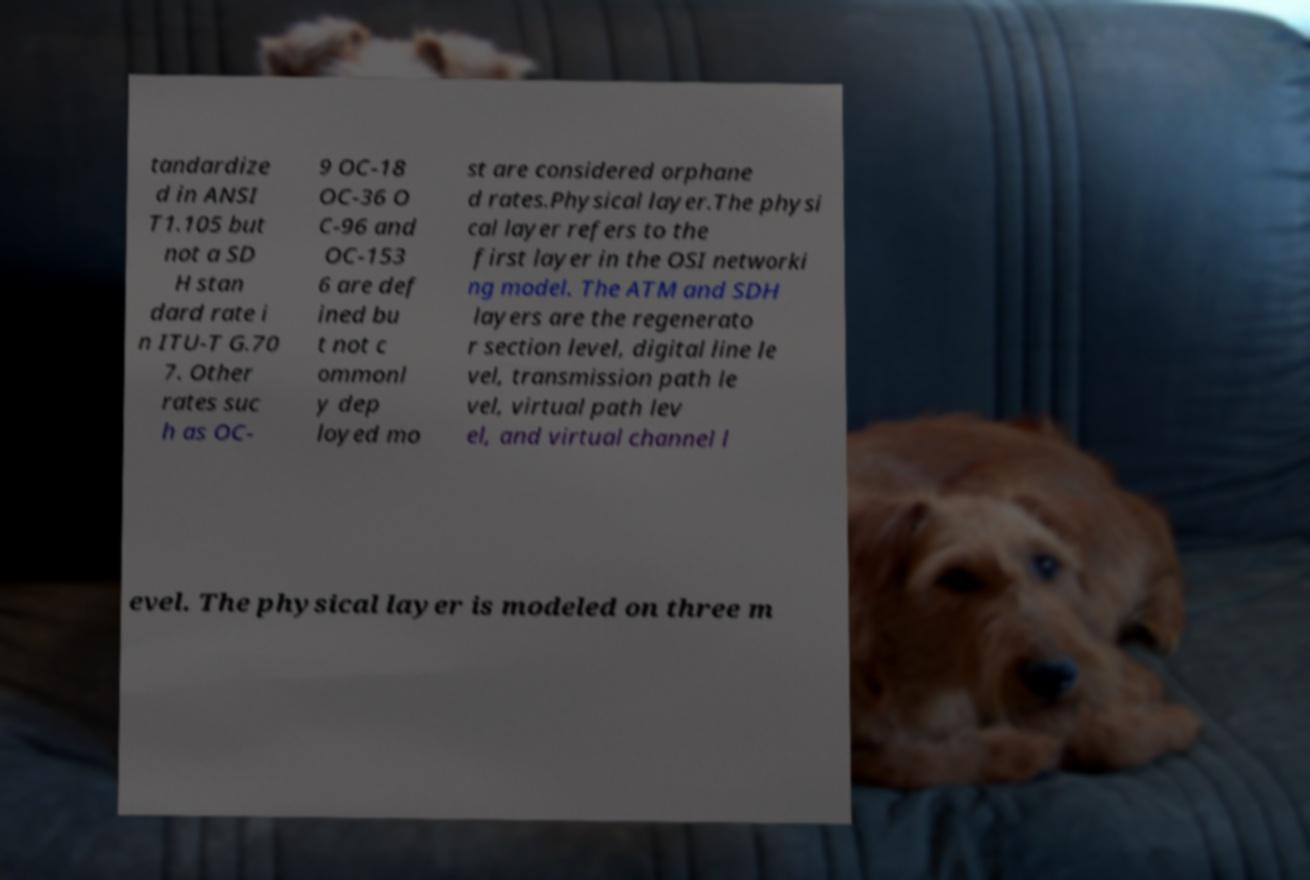Could you assist in decoding the text presented in this image and type it out clearly? tandardize d in ANSI T1.105 but not a SD H stan dard rate i n ITU-T G.70 7. Other rates suc h as OC- 9 OC-18 OC-36 O C-96 and OC-153 6 are def ined bu t not c ommonl y dep loyed mo st are considered orphane d rates.Physical layer.The physi cal layer refers to the first layer in the OSI networki ng model. The ATM and SDH layers are the regenerato r section level, digital line le vel, transmission path le vel, virtual path lev el, and virtual channel l evel. The physical layer is modeled on three m 